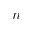Convert formula to latex. <formula><loc_0><loc_0><loc_500><loc_500>n</formula> 